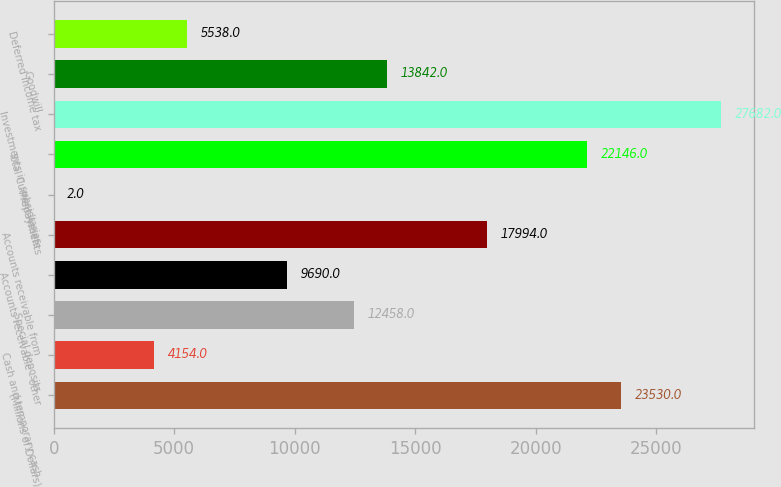Convert chart. <chart><loc_0><loc_0><loc_500><loc_500><bar_chart><fcel>(Millions of Dollars)<fcel>Cash and temporary cash<fcel>Special deposits<fcel>Accounts receivable - other<fcel>Accounts receivable from<fcel>Prepayments<fcel>Total Current Assets<fcel>Investments in subsidiaries<fcel>Goodwill<fcel>Deferred income tax<nl><fcel>23530<fcel>4154<fcel>12458<fcel>9690<fcel>17994<fcel>2<fcel>22146<fcel>27682<fcel>13842<fcel>5538<nl></chart> 